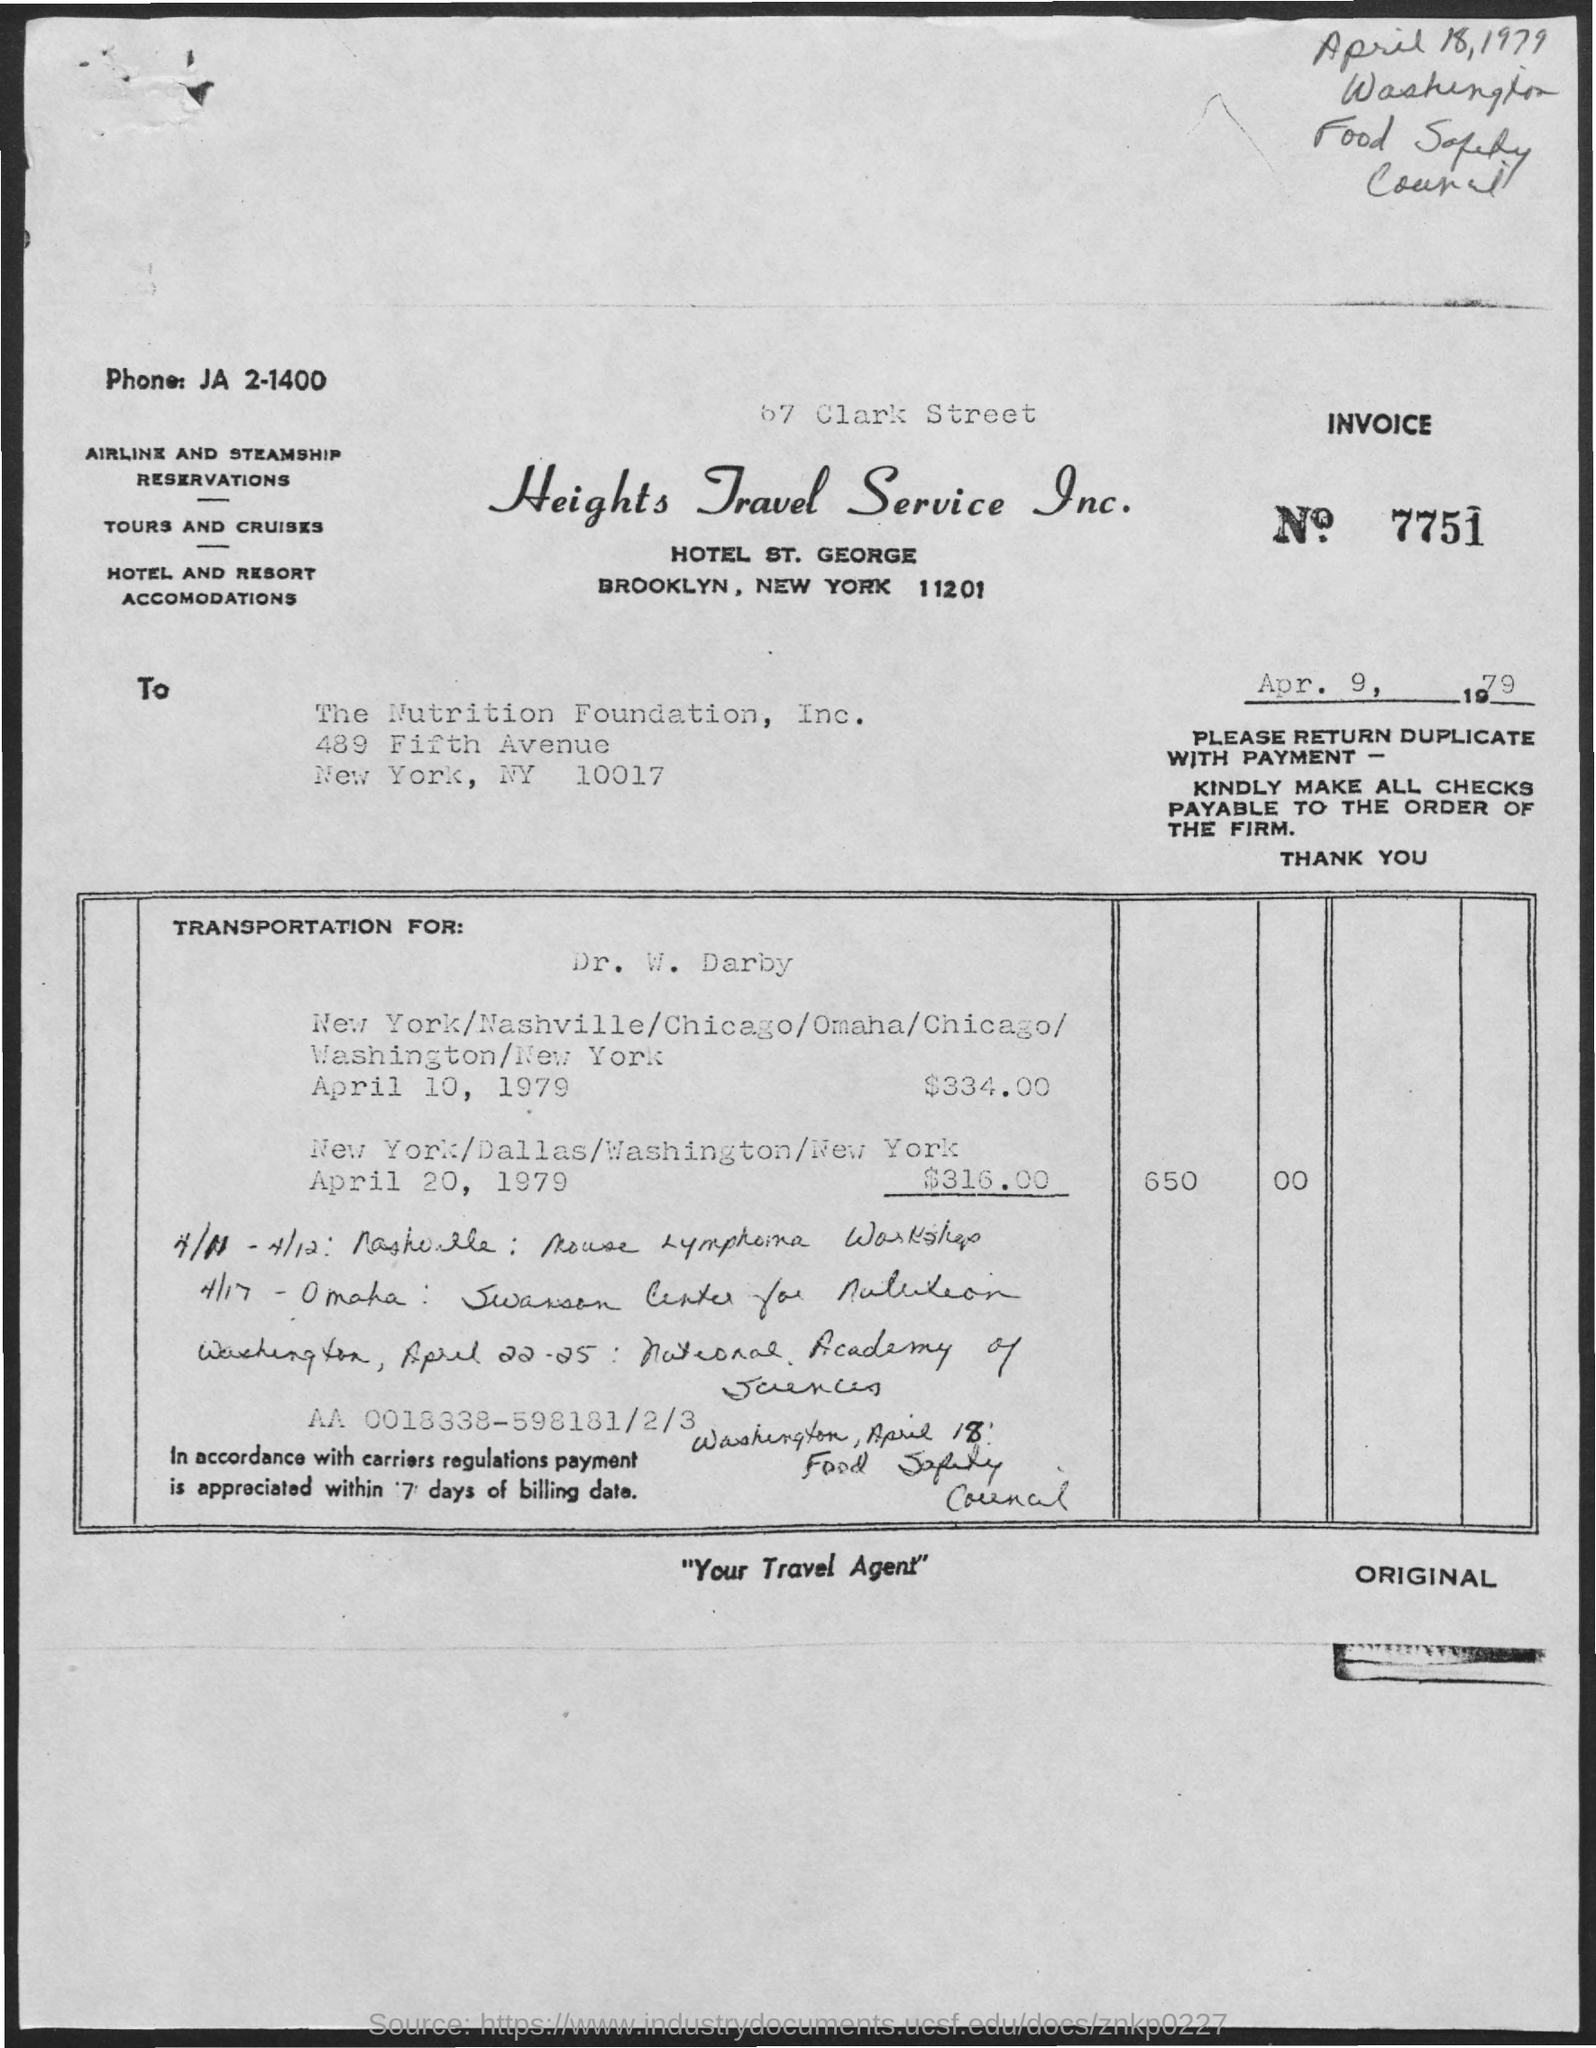List a handful of essential elements in this visual. The invoice number mentioned in this document is 7751. The invoice amount for transportation services provided by Dr. W. Darby on April 10, 1979, was $334.00. The issued date of the invoice is April 9, 1979. The total invoice amount as per the document is 650. The phone number listed on the invoice is JA 2-1400. 